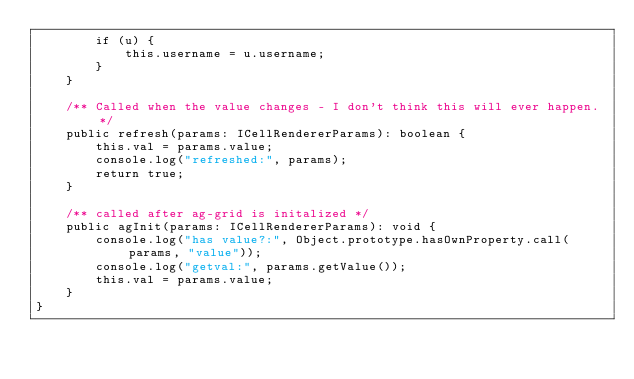<code> <loc_0><loc_0><loc_500><loc_500><_TypeScript_>		if (u) {
			this.username = u.username;
		}
	}

	/** Called when the value changes - I don't think this will ever happen. */
	public refresh(params: ICellRendererParams): boolean {
		this.val = params.value;
		console.log("refreshed:", params);
		return true;
	}

	/** called after ag-grid is initalized */
	public agInit(params: ICellRendererParams): void {
		console.log("has value?:", Object.prototype.hasOwnProperty.call(params, "value"));
		console.log("getval:", params.getValue());
		this.val = params.value;
	}
}
</code> 